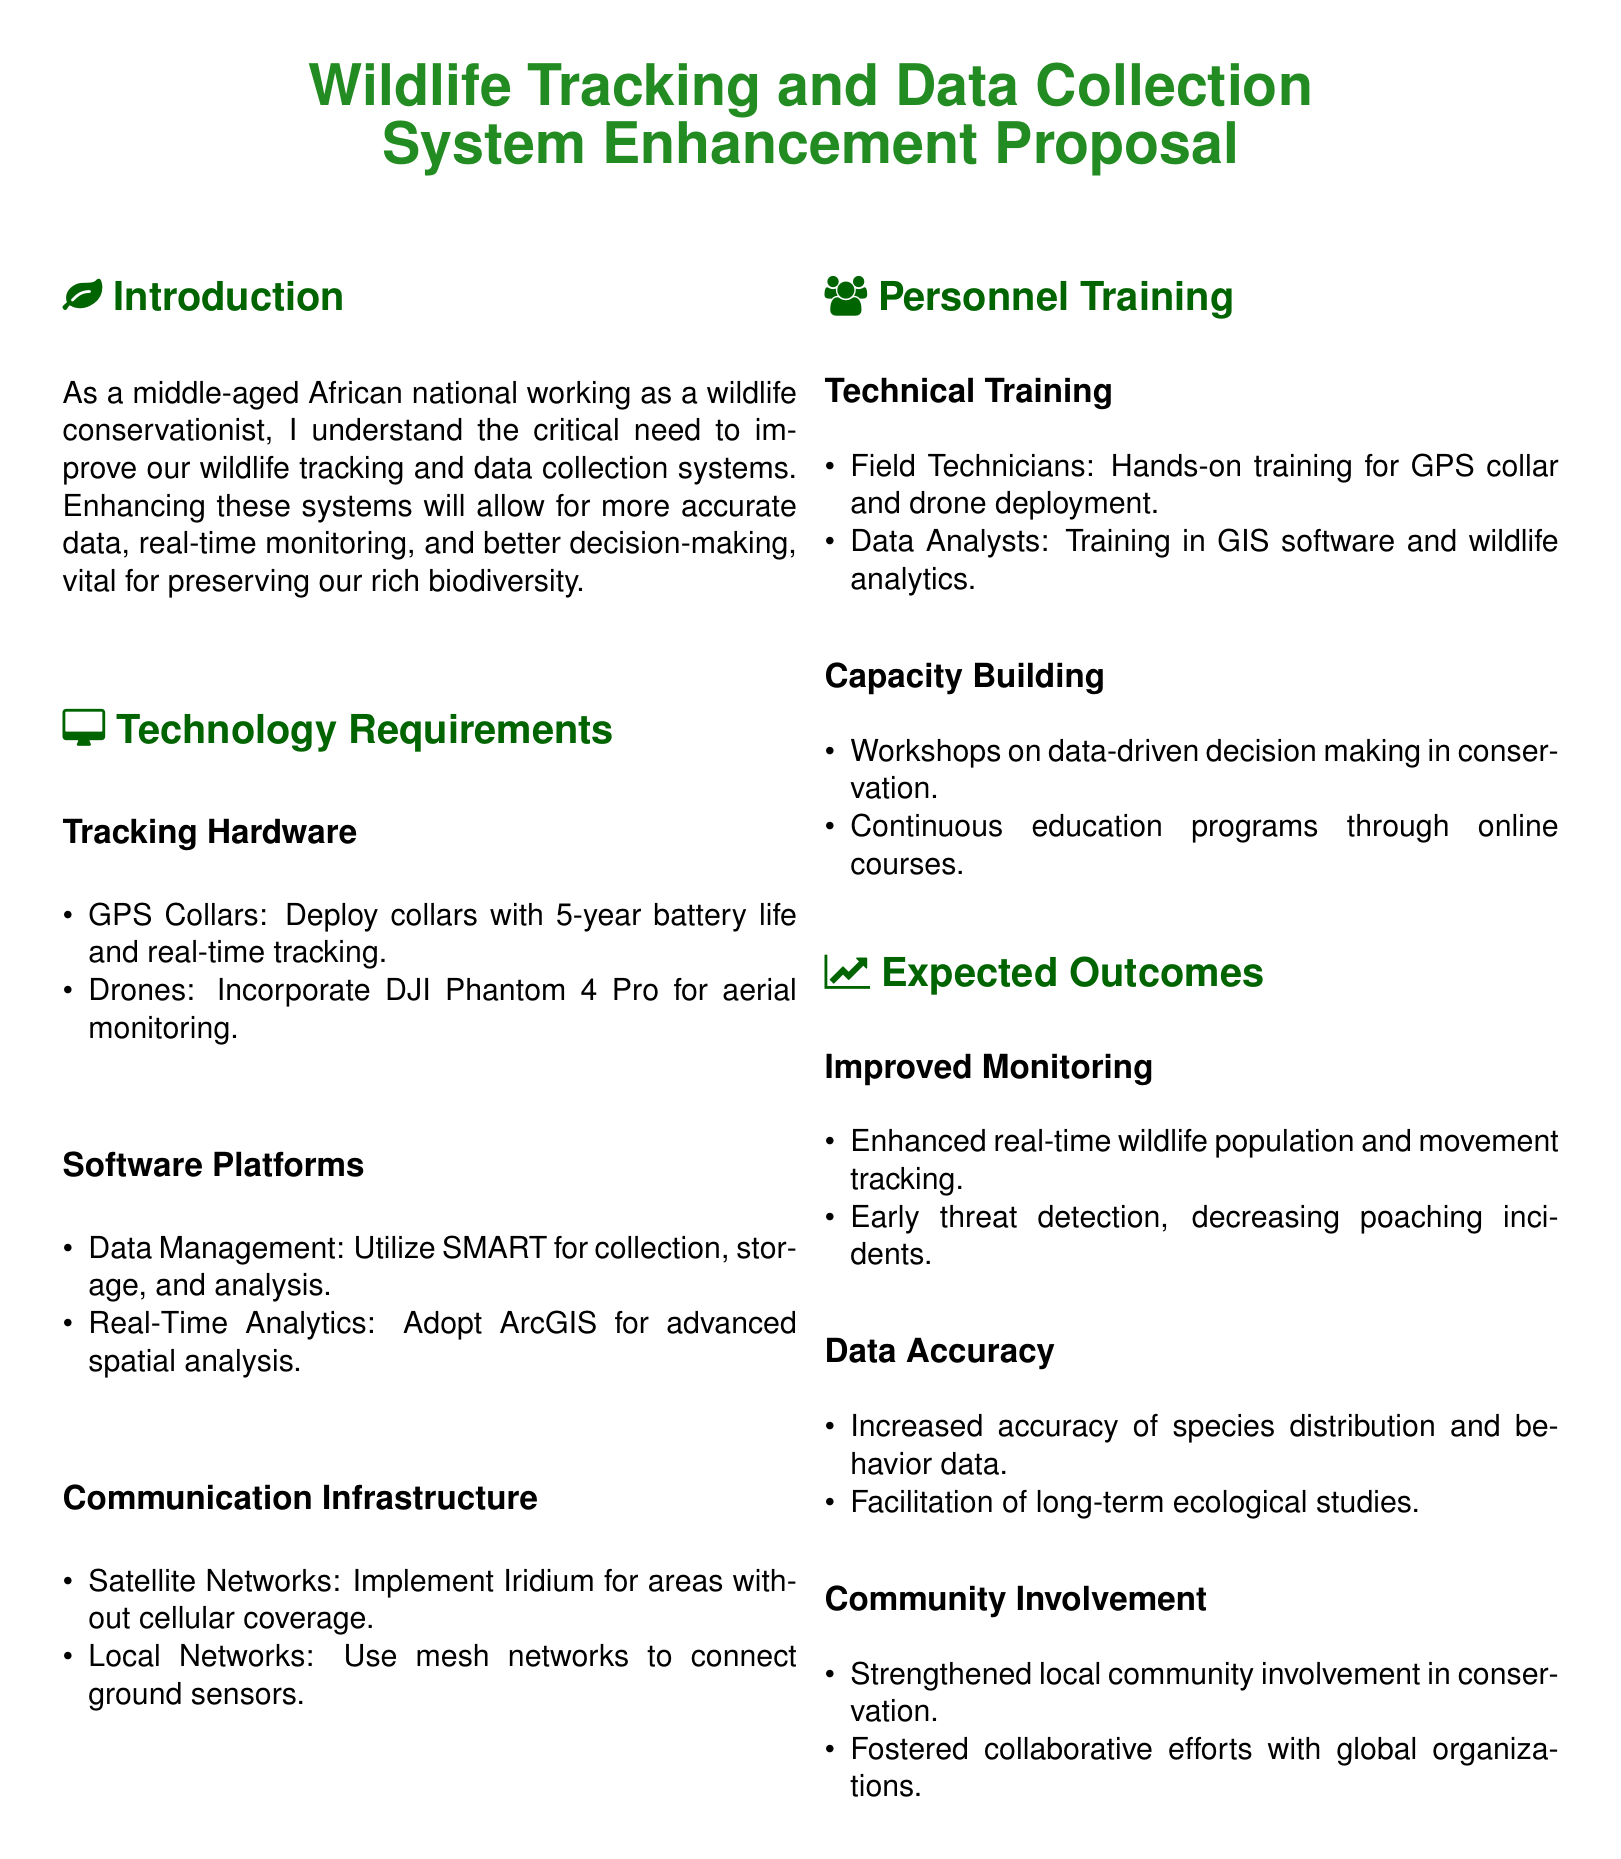What is the main focus of the proposal? The proposal focuses on improving wildlife tracking and data collection systems to enhance monitoring and decision-making.
Answer: Improving wildlife tracking and data collection systems How long is the battery life of GPS collars? The document states that the GPS collars have a battery life of 5 years.
Answer: 5 years What type of drone is mentioned for aerial monitoring? The proposal specifies the use of DJI Phantom 4 Pro for aerial monitoring.
Answer: DJI Phantom 4 Pro What software is designated for data management? SMART is indicated as the software for collection, storage, and analysis of data.
Answer: SMART What is one expected outcome regarding community involvement? The proposal highlights strengthened local community involvement in conservation as an expected outcome.
Answer: Strengthened local community involvement How many types of training are mentioned for personnel? There are two types of training mentioned: technical training and capacity building.
Answer: Two What is the key technology for areas without cellular coverage? The proposal suggests implementing Iridium satellite networks for remote areas.
Answer: Iridium What is a specific type of workshop included in capacity building? The proposal mentions workshops on data-driven decision making in conservation.
Answer: Data-driven decision making workshops 